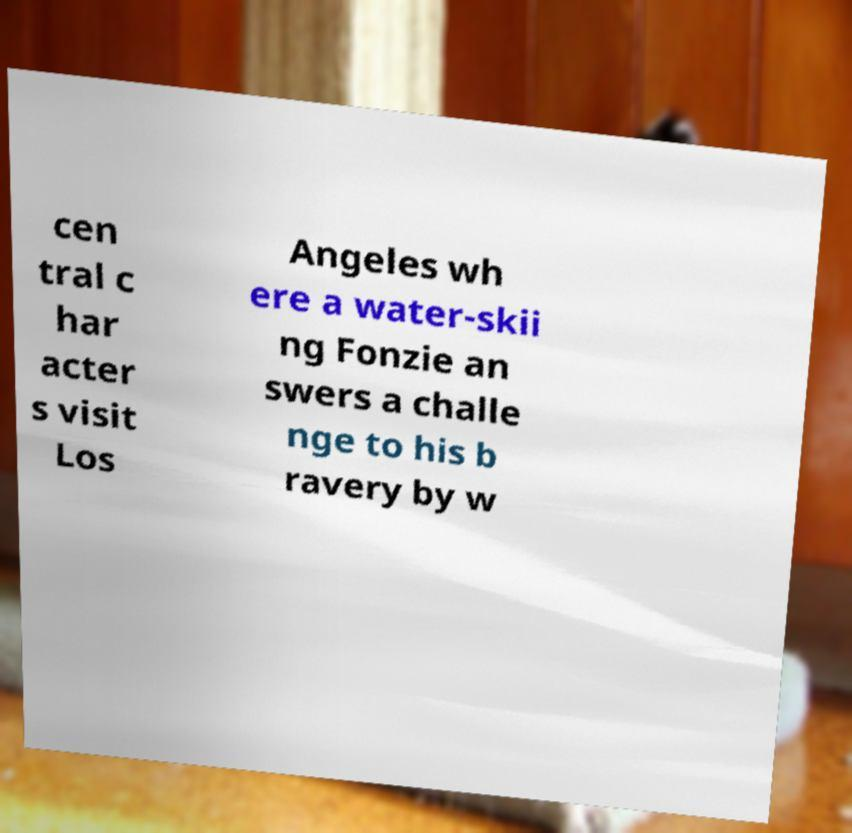Can you read and provide the text displayed in the image?This photo seems to have some interesting text. Can you extract and type it out for me? cen tral c har acter s visit Los Angeles wh ere a water-skii ng Fonzie an swers a challe nge to his b ravery by w 